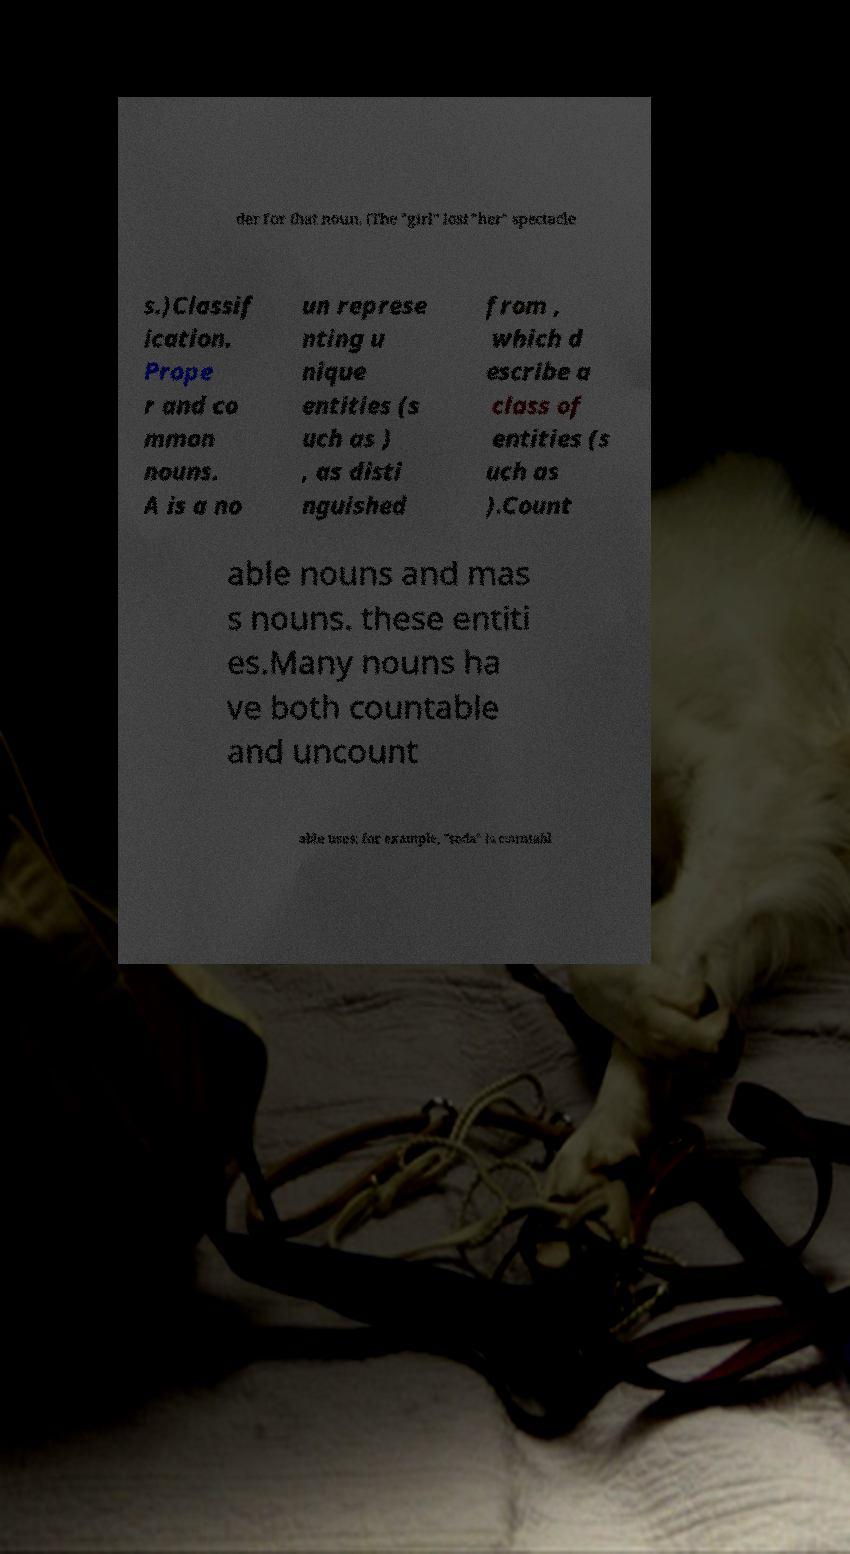Can you read and provide the text displayed in the image?This photo seems to have some interesting text. Can you extract and type it out for me? der for that noun. (The "girl" lost "her" spectacle s.)Classif ication. Prope r and co mmon nouns. A is a no un represe nting u nique entities (s uch as ) , as disti nguished from , which d escribe a class of entities (s uch as ).Count able nouns and mas s nouns. these entiti es.Many nouns ha ve both countable and uncount able uses; for example, "soda" is countabl 